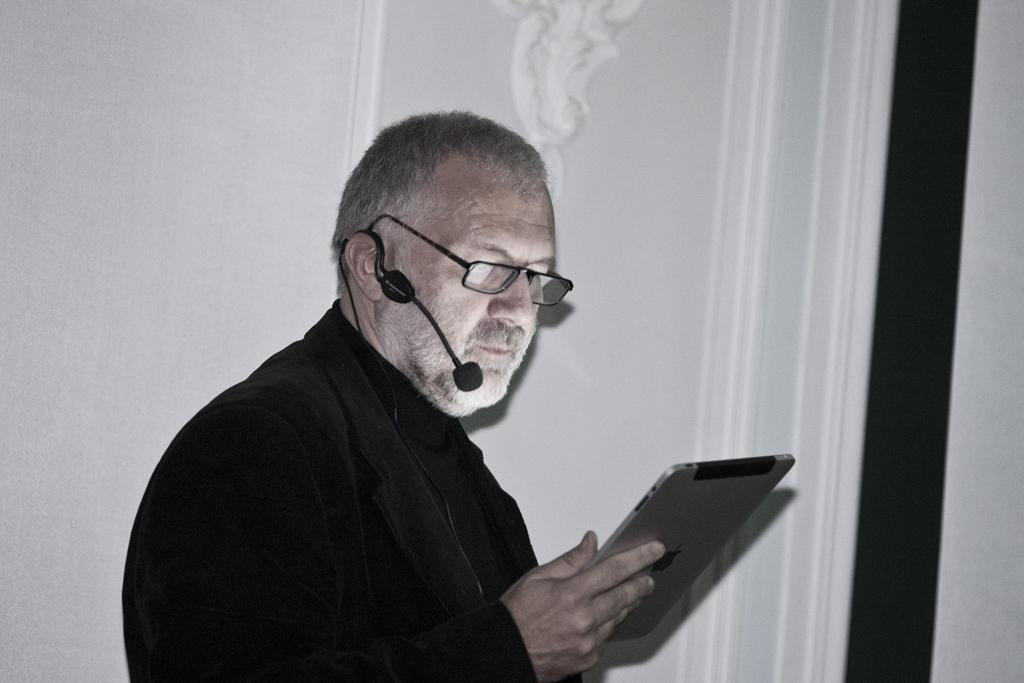What is the main subject of the image? The main subject of the image is a man standing in the middle. What is the man holding in the image? The man is holding a tab in the image. What is the man doing with the tab? The man is looking at the tab in the image. What can be seen behind the man? There is a wall behind the man in the image. How many kittens are climbing on the root in the image? There are no kittens or roots present in the image. What type of cakes are being served at the event in the image? There is no event or cakes depicted in the image. 